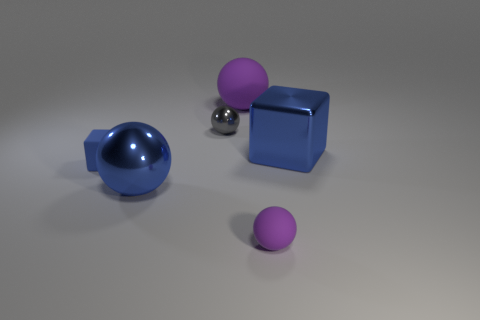Is the number of tiny metal balls on the right side of the small purple sphere the same as the number of metallic things?
Offer a very short reply. No. How many objects are big balls that are to the left of the large purple matte object or metal spheres?
Make the answer very short. 2. Is the color of the matte object in front of the rubber block the same as the big matte sphere?
Your answer should be compact. Yes. There is a purple rubber thing that is right of the big purple rubber thing; what size is it?
Give a very brief answer. Small. What is the shape of the purple thing behind the metallic thing on the right side of the small gray shiny ball?
Give a very brief answer. Sphere. What is the color of the other matte thing that is the same shape as the large purple matte thing?
Give a very brief answer. Purple. There is a cube to the left of the shiny cube; is its size the same as the gray metal object?
Make the answer very short. Yes. What shape is the tiny thing that is the same color as the large metallic cube?
Provide a succinct answer. Cube. What number of small purple things have the same material as the tiny cube?
Your answer should be very brief. 1. What material is the purple object in front of the large sphere in front of the purple rubber thing that is behind the tiny rubber ball made of?
Give a very brief answer. Rubber. 